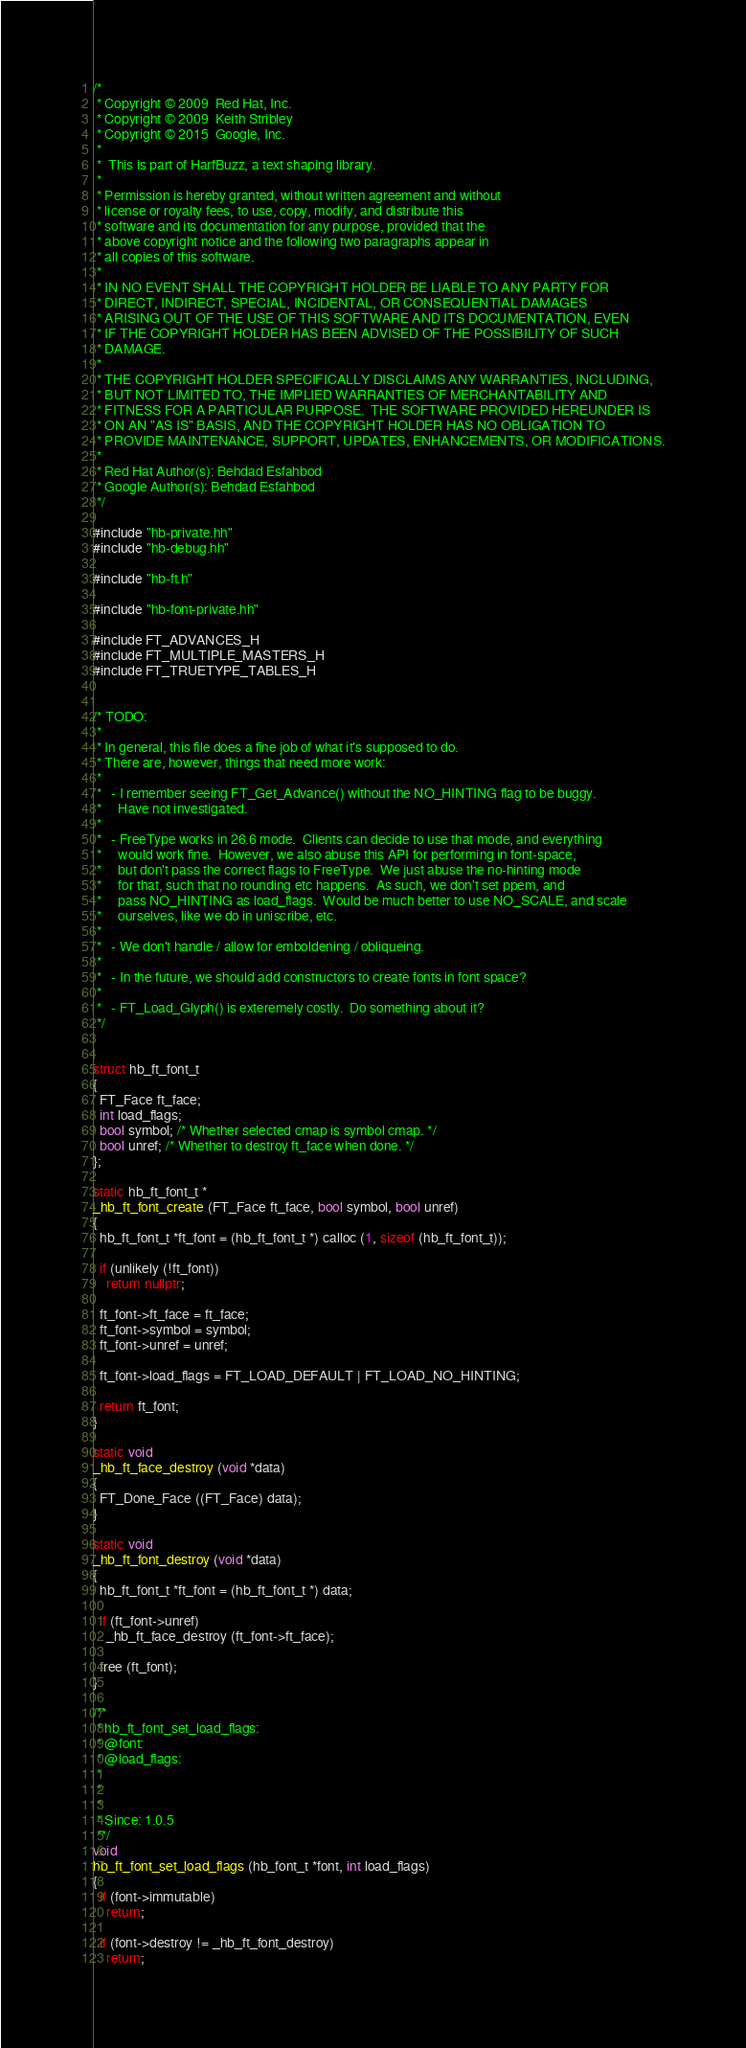<code> <loc_0><loc_0><loc_500><loc_500><_C++_>/*
 * Copyright © 2009  Red Hat, Inc.
 * Copyright © 2009  Keith Stribley
 * Copyright © 2015  Google, Inc.
 *
 *  This is part of HarfBuzz, a text shaping library.
 *
 * Permission is hereby granted, without written agreement and without
 * license or royalty fees, to use, copy, modify, and distribute this
 * software and its documentation for any purpose, provided that the
 * above copyright notice and the following two paragraphs appear in
 * all copies of this software.
 *
 * IN NO EVENT SHALL THE COPYRIGHT HOLDER BE LIABLE TO ANY PARTY FOR
 * DIRECT, INDIRECT, SPECIAL, INCIDENTAL, OR CONSEQUENTIAL DAMAGES
 * ARISING OUT OF THE USE OF THIS SOFTWARE AND ITS DOCUMENTATION, EVEN
 * IF THE COPYRIGHT HOLDER HAS BEEN ADVISED OF THE POSSIBILITY OF SUCH
 * DAMAGE.
 *
 * THE COPYRIGHT HOLDER SPECIFICALLY DISCLAIMS ANY WARRANTIES, INCLUDING,
 * BUT NOT LIMITED TO, THE IMPLIED WARRANTIES OF MERCHANTABILITY AND
 * FITNESS FOR A PARTICULAR PURPOSE.  THE SOFTWARE PROVIDED HEREUNDER IS
 * ON AN "AS IS" BASIS, AND THE COPYRIGHT HOLDER HAS NO OBLIGATION TO
 * PROVIDE MAINTENANCE, SUPPORT, UPDATES, ENHANCEMENTS, OR MODIFICATIONS.
 *
 * Red Hat Author(s): Behdad Esfahbod
 * Google Author(s): Behdad Esfahbod
 */

#include "hb-private.hh"
#include "hb-debug.hh"

#include "hb-ft.h"

#include "hb-font-private.hh"

#include FT_ADVANCES_H
#include FT_MULTIPLE_MASTERS_H
#include FT_TRUETYPE_TABLES_H


/* TODO:
 *
 * In general, this file does a fine job of what it's supposed to do.
 * There are, however, things that need more work:
 *
 *   - I remember seeing FT_Get_Advance() without the NO_HINTING flag to be buggy.
 *     Have not investigated.
 *
 *   - FreeType works in 26.6 mode.  Clients can decide to use that mode, and everything
 *     would work fine.  However, we also abuse this API for performing in font-space,
 *     but don't pass the correct flags to FreeType.  We just abuse the no-hinting mode
 *     for that, such that no rounding etc happens.  As such, we don't set ppem, and
 *     pass NO_HINTING as load_flags.  Would be much better to use NO_SCALE, and scale
 *     ourselves, like we do in uniscribe, etc.
 *
 *   - We don't handle / allow for emboldening / obliqueing.
 *
 *   - In the future, we should add constructors to create fonts in font space?
 *
 *   - FT_Load_Glyph() is exteremely costly.  Do something about it?
 */


struct hb_ft_font_t
{
  FT_Face ft_face;
  int load_flags;
  bool symbol; /* Whether selected cmap is symbol cmap. */
  bool unref; /* Whether to destroy ft_face when done. */
};

static hb_ft_font_t *
_hb_ft_font_create (FT_Face ft_face, bool symbol, bool unref)
{
  hb_ft_font_t *ft_font = (hb_ft_font_t *) calloc (1, sizeof (hb_ft_font_t));

  if (unlikely (!ft_font))
    return nullptr;

  ft_font->ft_face = ft_face;
  ft_font->symbol = symbol;
  ft_font->unref = unref;

  ft_font->load_flags = FT_LOAD_DEFAULT | FT_LOAD_NO_HINTING;

  return ft_font;
}

static void
_hb_ft_face_destroy (void *data)
{
  FT_Done_Face ((FT_Face) data);
}

static void
_hb_ft_font_destroy (void *data)
{
  hb_ft_font_t *ft_font = (hb_ft_font_t *) data;

  if (ft_font->unref)
    _hb_ft_face_destroy (ft_font->ft_face);

  free (ft_font);
}

/**
 * hb_ft_font_set_load_flags:
 * @font:
 * @load_flags:
 *
 * 
 *
 * Since: 1.0.5
 **/
void
hb_ft_font_set_load_flags (hb_font_t *font, int load_flags)
{
  if (font->immutable)
    return;

  if (font->destroy != _hb_ft_font_destroy)
    return;
</code> 